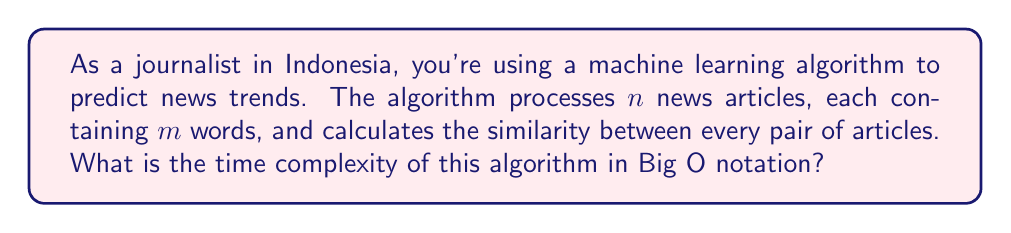Can you solve this math problem? Let's break down the problem and analyze it step by step:

1. We have $n$ news articles, each containing $m$ words.

2. To calculate the similarity between every pair of articles, we need to compare each article with every other article. This is a pairwise comparison.

3. The number of comparisons required is:
   $${n \choose 2} = \frac{n(n-1)}{2}$$

4. For each comparison, we need to process $m$ words from each of the two articles being compared. This means processing $2m$ words for each pair.

5. The total number of word comparisons is:
   $$\frac{n(n-1)}{2} \cdot 2m = mn(n-1)$$

6. As $n$ grows large, the $(n-1)$ term becomes less significant compared to $n$, so we can simplify this to $mn^2$.

7. In Big O notation, we drop constant factors and focus on the highest-order term. Therefore, the time complexity is $O(mn^2)$.

This quadratic time complexity in terms of the number of articles ($n$) indicates that the algorithm's processing time will grow quickly as the number of articles increases, which could be a concern for real-time trend analysis in a fast-paced news environment.
Answer: $O(mn^2)$ 